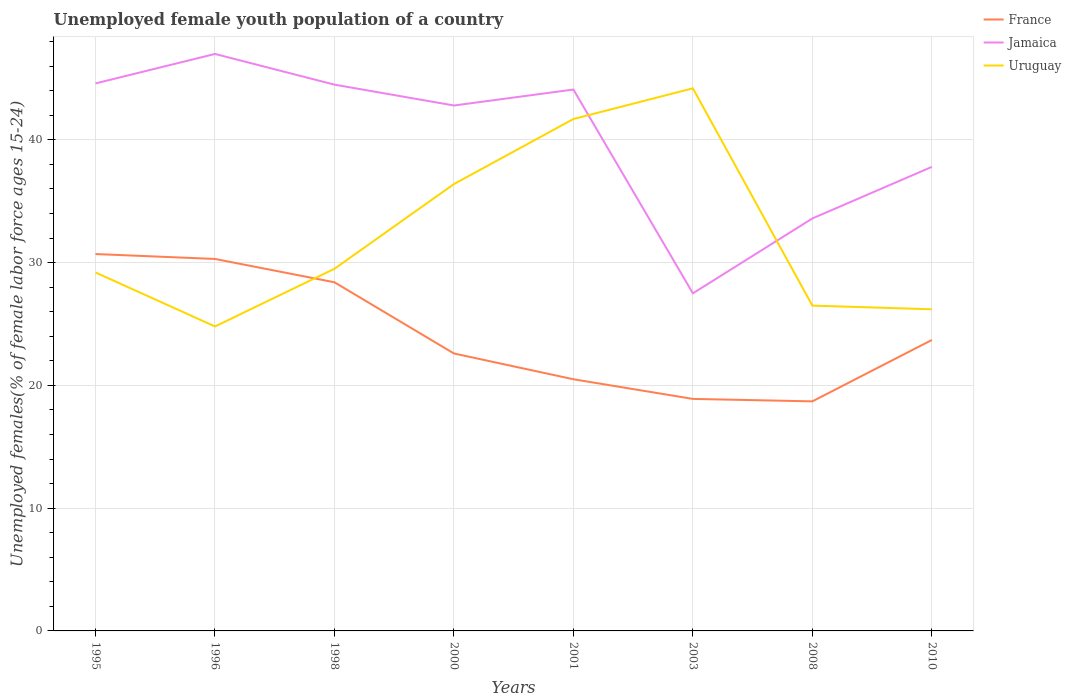Does the line corresponding to Jamaica intersect with the line corresponding to Uruguay?
Keep it short and to the point. Yes. What is the total percentage of unemployed female youth population in France in the graph?
Offer a very short reply. 6.6. What is the difference between the highest and the lowest percentage of unemployed female youth population in France?
Your answer should be compact. 3. How many years are there in the graph?
Your answer should be very brief. 8. What is the difference between two consecutive major ticks on the Y-axis?
Provide a short and direct response. 10. Are the values on the major ticks of Y-axis written in scientific E-notation?
Ensure brevity in your answer.  No. Does the graph contain any zero values?
Your answer should be compact. No. Does the graph contain grids?
Offer a very short reply. Yes. Where does the legend appear in the graph?
Your answer should be compact. Top right. What is the title of the graph?
Provide a succinct answer. Unemployed female youth population of a country. Does "Congo (Republic)" appear as one of the legend labels in the graph?
Keep it short and to the point. No. What is the label or title of the X-axis?
Provide a short and direct response. Years. What is the label or title of the Y-axis?
Ensure brevity in your answer.  Unemployed females(% of female labor force ages 15-24). What is the Unemployed females(% of female labor force ages 15-24) of France in 1995?
Provide a short and direct response. 30.7. What is the Unemployed females(% of female labor force ages 15-24) in Jamaica in 1995?
Ensure brevity in your answer.  44.6. What is the Unemployed females(% of female labor force ages 15-24) in Uruguay in 1995?
Offer a terse response. 29.2. What is the Unemployed females(% of female labor force ages 15-24) in France in 1996?
Your response must be concise. 30.3. What is the Unemployed females(% of female labor force ages 15-24) of Uruguay in 1996?
Your response must be concise. 24.8. What is the Unemployed females(% of female labor force ages 15-24) in France in 1998?
Provide a succinct answer. 28.4. What is the Unemployed females(% of female labor force ages 15-24) of Jamaica in 1998?
Provide a succinct answer. 44.5. What is the Unemployed females(% of female labor force ages 15-24) of Uruguay in 1998?
Offer a terse response. 29.5. What is the Unemployed females(% of female labor force ages 15-24) in France in 2000?
Make the answer very short. 22.6. What is the Unemployed females(% of female labor force ages 15-24) of Jamaica in 2000?
Give a very brief answer. 42.8. What is the Unemployed females(% of female labor force ages 15-24) in Uruguay in 2000?
Your response must be concise. 36.4. What is the Unemployed females(% of female labor force ages 15-24) of Jamaica in 2001?
Provide a short and direct response. 44.1. What is the Unemployed females(% of female labor force ages 15-24) of Uruguay in 2001?
Provide a short and direct response. 41.7. What is the Unemployed females(% of female labor force ages 15-24) of France in 2003?
Your answer should be compact. 18.9. What is the Unemployed females(% of female labor force ages 15-24) of Jamaica in 2003?
Provide a short and direct response. 27.5. What is the Unemployed females(% of female labor force ages 15-24) in Uruguay in 2003?
Ensure brevity in your answer.  44.2. What is the Unemployed females(% of female labor force ages 15-24) in France in 2008?
Offer a very short reply. 18.7. What is the Unemployed females(% of female labor force ages 15-24) of Jamaica in 2008?
Make the answer very short. 33.6. What is the Unemployed females(% of female labor force ages 15-24) in Uruguay in 2008?
Ensure brevity in your answer.  26.5. What is the Unemployed females(% of female labor force ages 15-24) of France in 2010?
Offer a terse response. 23.7. What is the Unemployed females(% of female labor force ages 15-24) of Jamaica in 2010?
Keep it short and to the point. 37.8. What is the Unemployed females(% of female labor force ages 15-24) in Uruguay in 2010?
Offer a terse response. 26.2. Across all years, what is the maximum Unemployed females(% of female labor force ages 15-24) in France?
Ensure brevity in your answer.  30.7. Across all years, what is the maximum Unemployed females(% of female labor force ages 15-24) in Uruguay?
Make the answer very short. 44.2. Across all years, what is the minimum Unemployed females(% of female labor force ages 15-24) in France?
Keep it short and to the point. 18.7. Across all years, what is the minimum Unemployed females(% of female labor force ages 15-24) in Uruguay?
Your answer should be very brief. 24.8. What is the total Unemployed females(% of female labor force ages 15-24) in France in the graph?
Provide a short and direct response. 193.8. What is the total Unemployed females(% of female labor force ages 15-24) of Jamaica in the graph?
Offer a very short reply. 321.9. What is the total Unemployed females(% of female labor force ages 15-24) in Uruguay in the graph?
Your response must be concise. 258.5. What is the difference between the Unemployed females(% of female labor force ages 15-24) in France in 1995 and that in 1996?
Give a very brief answer. 0.4. What is the difference between the Unemployed females(% of female labor force ages 15-24) in Uruguay in 1995 and that in 1996?
Offer a very short reply. 4.4. What is the difference between the Unemployed females(% of female labor force ages 15-24) of France in 1995 and that in 1998?
Provide a short and direct response. 2.3. What is the difference between the Unemployed females(% of female labor force ages 15-24) in Jamaica in 1995 and that in 1998?
Offer a very short reply. 0.1. What is the difference between the Unemployed females(% of female labor force ages 15-24) in France in 1995 and that in 2000?
Ensure brevity in your answer.  8.1. What is the difference between the Unemployed females(% of female labor force ages 15-24) in France in 1995 and that in 2008?
Provide a succinct answer. 12. What is the difference between the Unemployed females(% of female labor force ages 15-24) of Uruguay in 1995 and that in 2010?
Provide a short and direct response. 3. What is the difference between the Unemployed females(% of female labor force ages 15-24) of France in 1996 and that in 1998?
Your answer should be compact. 1.9. What is the difference between the Unemployed females(% of female labor force ages 15-24) of Jamaica in 1996 and that in 1998?
Make the answer very short. 2.5. What is the difference between the Unemployed females(% of female labor force ages 15-24) in Uruguay in 1996 and that in 1998?
Provide a short and direct response. -4.7. What is the difference between the Unemployed females(% of female labor force ages 15-24) of France in 1996 and that in 2000?
Offer a very short reply. 7.7. What is the difference between the Unemployed females(% of female labor force ages 15-24) of Uruguay in 1996 and that in 2000?
Give a very brief answer. -11.6. What is the difference between the Unemployed females(% of female labor force ages 15-24) in Uruguay in 1996 and that in 2001?
Your answer should be very brief. -16.9. What is the difference between the Unemployed females(% of female labor force ages 15-24) in Jamaica in 1996 and that in 2003?
Keep it short and to the point. 19.5. What is the difference between the Unemployed females(% of female labor force ages 15-24) of Uruguay in 1996 and that in 2003?
Keep it short and to the point. -19.4. What is the difference between the Unemployed females(% of female labor force ages 15-24) of France in 1996 and that in 2008?
Offer a terse response. 11.6. What is the difference between the Unemployed females(% of female labor force ages 15-24) in Jamaica in 1996 and that in 2008?
Make the answer very short. 13.4. What is the difference between the Unemployed females(% of female labor force ages 15-24) of Uruguay in 1996 and that in 2008?
Provide a succinct answer. -1.7. What is the difference between the Unemployed females(% of female labor force ages 15-24) in France in 1996 and that in 2010?
Your answer should be very brief. 6.6. What is the difference between the Unemployed females(% of female labor force ages 15-24) of Uruguay in 1996 and that in 2010?
Provide a succinct answer. -1.4. What is the difference between the Unemployed females(% of female labor force ages 15-24) in Uruguay in 1998 and that in 2000?
Make the answer very short. -6.9. What is the difference between the Unemployed females(% of female labor force ages 15-24) of Jamaica in 1998 and that in 2001?
Your answer should be very brief. 0.4. What is the difference between the Unemployed females(% of female labor force ages 15-24) of France in 1998 and that in 2003?
Keep it short and to the point. 9.5. What is the difference between the Unemployed females(% of female labor force ages 15-24) in Jamaica in 1998 and that in 2003?
Offer a very short reply. 17. What is the difference between the Unemployed females(% of female labor force ages 15-24) of Uruguay in 1998 and that in 2003?
Make the answer very short. -14.7. What is the difference between the Unemployed females(% of female labor force ages 15-24) in France in 1998 and that in 2010?
Ensure brevity in your answer.  4.7. What is the difference between the Unemployed females(% of female labor force ages 15-24) of Jamaica in 1998 and that in 2010?
Provide a succinct answer. 6.7. What is the difference between the Unemployed females(% of female labor force ages 15-24) in France in 2000 and that in 2003?
Make the answer very short. 3.7. What is the difference between the Unemployed females(% of female labor force ages 15-24) of Uruguay in 2000 and that in 2003?
Provide a short and direct response. -7.8. What is the difference between the Unemployed females(% of female labor force ages 15-24) in France in 2000 and that in 2008?
Ensure brevity in your answer.  3.9. What is the difference between the Unemployed females(% of female labor force ages 15-24) in Jamaica in 2000 and that in 2010?
Your response must be concise. 5. What is the difference between the Unemployed females(% of female labor force ages 15-24) of Uruguay in 2000 and that in 2010?
Ensure brevity in your answer.  10.2. What is the difference between the Unemployed females(% of female labor force ages 15-24) in Jamaica in 2001 and that in 2003?
Keep it short and to the point. 16.6. What is the difference between the Unemployed females(% of female labor force ages 15-24) of France in 2001 and that in 2008?
Your answer should be very brief. 1.8. What is the difference between the Unemployed females(% of female labor force ages 15-24) in Jamaica in 2001 and that in 2008?
Your response must be concise. 10.5. What is the difference between the Unemployed females(% of female labor force ages 15-24) of France in 2003 and that in 2008?
Your answer should be compact. 0.2. What is the difference between the Unemployed females(% of female labor force ages 15-24) of Uruguay in 2003 and that in 2008?
Provide a succinct answer. 17.7. What is the difference between the Unemployed females(% of female labor force ages 15-24) of France in 2003 and that in 2010?
Make the answer very short. -4.8. What is the difference between the Unemployed females(% of female labor force ages 15-24) in France in 2008 and that in 2010?
Keep it short and to the point. -5. What is the difference between the Unemployed females(% of female labor force ages 15-24) of Uruguay in 2008 and that in 2010?
Make the answer very short. 0.3. What is the difference between the Unemployed females(% of female labor force ages 15-24) of France in 1995 and the Unemployed females(% of female labor force ages 15-24) of Jamaica in 1996?
Offer a terse response. -16.3. What is the difference between the Unemployed females(% of female labor force ages 15-24) in Jamaica in 1995 and the Unemployed females(% of female labor force ages 15-24) in Uruguay in 1996?
Your answer should be very brief. 19.8. What is the difference between the Unemployed females(% of female labor force ages 15-24) of Jamaica in 1995 and the Unemployed females(% of female labor force ages 15-24) of Uruguay in 1998?
Make the answer very short. 15.1. What is the difference between the Unemployed females(% of female labor force ages 15-24) of France in 1995 and the Unemployed females(% of female labor force ages 15-24) of Uruguay in 2000?
Your answer should be very brief. -5.7. What is the difference between the Unemployed females(% of female labor force ages 15-24) of Jamaica in 1995 and the Unemployed females(% of female labor force ages 15-24) of Uruguay in 2000?
Offer a very short reply. 8.2. What is the difference between the Unemployed females(% of female labor force ages 15-24) of France in 1995 and the Unemployed females(% of female labor force ages 15-24) of Jamaica in 2001?
Your response must be concise. -13.4. What is the difference between the Unemployed females(% of female labor force ages 15-24) in Jamaica in 1995 and the Unemployed females(% of female labor force ages 15-24) in Uruguay in 2001?
Ensure brevity in your answer.  2.9. What is the difference between the Unemployed females(% of female labor force ages 15-24) in Jamaica in 1995 and the Unemployed females(% of female labor force ages 15-24) in Uruguay in 2003?
Provide a short and direct response. 0.4. What is the difference between the Unemployed females(% of female labor force ages 15-24) in France in 1995 and the Unemployed females(% of female labor force ages 15-24) in Jamaica in 2008?
Provide a short and direct response. -2.9. What is the difference between the Unemployed females(% of female labor force ages 15-24) of France in 1995 and the Unemployed females(% of female labor force ages 15-24) of Uruguay in 2008?
Your answer should be very brief. 4.2. What is the difference between the Unemployed females(% of female labor force ages 15-24) of Jamaica in 1996 and the Unemployed females(% of female labor force ages 15-24) of Uruguay in 1998?
Offer a very short reply. 17.5. What is the difference between the Unemployed females(% of female labor force ages 15-24) in France in 1996 and the Unemployed females(% of female labor force ages 15-24) in Uruguay in 2000?
Make the answer very short. -6.1. What is the difference between the Unemployed females(% of female labor force ages 15-24) in Jamaica in 1996 and the Unemployed females(% of female labor force ages 15-24) in Uruguay in 2000?
Keep it short and to the point. 10.6. What is the difference between the Unemployed females(% of female labor force ages 15-24) in France in 1996 and the Unemployed females(% of female labor force ages 15-24) in Jamaica in 2001?
Provide a succinct answer. -13.8. What is the difference between the Unemployed females(% of female labor force ages 15-24) in France in 1996 and the Unemployed females(% of female labor force ages 15-24) in Uruguay in 2001?
Give a very brief answer. -11.4. What is the difference between the Unemployed females(% of female labor force ages 15-24) in Jamaica in 1996 and the Unemployed females(% of female labor force ages 15-24) in Uruguay in 2001?
Keep it short and to the point. 5.3. What is the difference between the Unemployed females(% of female labor force ages 15-24) in France in 1996 and the Unemployed females(% of female labor force ages 15-24) in Jamaica in 2003?
Offer a terse response. 2.8. What is the difference between the Unemployed females(% of female labor force ages 15-24) of France in 1996 and the Unemployed females(% of female labor force ages 15-24) of Uruguay in 2008?
Provide a succinct answer. 3.8. What is the difference between the Unemployed females(% of female labor force ages 15-24) in Jamaica in 1996 and the Unemployed females(% of female labor force ages 15-24) in Uruguay in 2010?
Provide a succinct answer. 20.8. What is the difference between the Unemployed females(% of female labor force ages 15-24) in France in 1998 and the Unemployed females(% of female labor force ages 15-24) in Jamaica in 2000?
Your answer should be very brief. -14.4. What is the difference between the Unemployed females(% of female labor force ages 15-24) of Jamaica in 1998 and the Unemployed females(% of female labor force ages 15-24) of Uruguay in 2000?
Give a very brief answer. 8.1. What is the difference between the Unemployed females(% of female labor force ages 15-24) of France in 1998 and the Unemployed females(% of female labor force ages 15-24) of Jamaica in 2001?
Ensure brevity in your answer.  -15.7. What is the difference between the Unemployed females(% of female labor force ages 15-24) in Jamaica in 1998 and the Unemployed females(% of female labor force ages 15-24) in Uruguay in 2001?
Keep it short and to the point. 2.8. What is the difference between the Unemployed females(% of female labor force ages 15-24) in France in 1998 and the Unemployed females(% of female labor force ages 15-24) in Uruguay in 2003?
Make the answer very short. -15.8. What is the difference between the Unemployed females(% of female labor force ages 15-24) in Jamaica in 1998 and the Unemployed females(% of female labor force ages 15-24) in Uruguay in 2003?
Provide a succinct answer. 0.3. What is the difference between the Unemployed females(% of female labor force ages 15-24) in France in 1998 and the Unemployed females(% of female labor force ages 15-24) in Jamaica in 2008?
Offer a very short reply. -5.2. What is the difference between the Unemployed females(% of female labor force ages 15-24) of Jamaica in 1998 and the Unemployed females(% of female labor force ages 15-24) of Uruguay in 2008?
Ensure brevity in your answer.  18. What is the difference between the Unemployed females(% of female labor force ages 15-24) of France in 1998 and the Unemployed females(% of female labor force ages 15-24) of Uruguay in 2010?
Provide a succinct answer. 2.2. What is the difference between the Unemployed females(% of female labor force ages 15-24) of France in 2000 and the Unemployed females(% of female labor force ages 15-24) of Jamaica in 2001?
Make the answer very short. -21.5. What is the difference between the Unemployed females(% of female labor force ages 15-24) of France in 2000 and the Unemployed females(% of female labor force ages 15-24) of Uruguay in 2001?
Your answer should be compact. -19.1. What is the difference between the Unemployed females(% of female labor force ages 15-24) in France in 2000 and the Unemployed females(% of female labor force ages 15-24) in Uruguay in 2003?
Your response must be concise. -21.6. What is the difference between the Unemployed females(% of female labor force ages 15-24) in France in 2000 and the Unemployed females(% of female labor force ages 15-24) in Jamaica in 2008?
Keep it short and to the point. -11. What is the difference between the Unemployed females(% of female labor force ages 15-24) of France in 2000 and the Unemployed females(% of female labor force ages 15-24) of Jamaica in 2010?
Keep it short and to the point. -15.2. What is the difference between the Unemployed females(% of female labor force ages 15-24) of France in 2001 and the Unemployed females(% of female labor force ages 15-24) of Uruguay in 2003?
Keep it short and to the point. -23.7. What is the difference between the Unemployed females(% of female labor force ages 15-24) of Jamaica in 2001 and the Unemployed females(% of female labor force ages 15-24) of Uruguay in 2003?
Make the answer very short. -0.1. What is the difference between the Unemployed females(% of female labor force ages 15-24) of France in 2001 and the Unemployed females(% of female labor force ages 15-24) of Jamaica in 2008?
Your response must be concise. -13.1. What is the difference between the Unemployed females(% of female labor force ages 15-24) in Jamaica in 2001 and the Unemployed females(% of female labor force ages 15-24) in Uruguay in 2008?
Ensure brevity in your answer.  17.6. What is the difference between the Unemployed females(% of female labor force ages 15-24) in France in 2001 and the Unemployed females(% of female labor force ages 15-24) in Jamaica in 2010?
Provide a succinct answer. -17.3. What is the difference between the Unemployed females(% of female labor force ages 15-24) in France in 2001 and the Unemployed females(% of female labor force ages 15-24) in Uruguay in 2010?
Offer a very short reply. -5.7. What is the difference between the Unemployed females(% of female labor force ages 15-24) of Jamaica in 2001 and the Unemployed females(% of female labor force ages 15-24) of Uruguay in 2010?
Your answer should be compact. 17.9. What is the difference between the Unemployed females(% of female labor force ages 15-24) of France in 2003 and the Unemployed females(% of female labor force ages 15-24) of Jamaica in 2008?
Provide a succinct answer. -14.7. What is the difference between the Unemployed females(% of female labor force ages 15-24) of France in 2003 and the Unemployed females(% of female labor force ages 15-24) of Jamaica in 2010?
Your answer should be very brief. -18.9. What is the difference between the Unemployed females(% of female labor force ages 15-24) in France in 2003 and the Unemployed females(% of female labor force ages 15-24) in Uruguay in 2010?
Your answer should be very brief. -7.3. What is the difference between the Unemployed females(% of female labor force ages 15-24) in France in 2008 and the Unemployed females(% of female labor force ages 15-24) in Jamaica in 2010?
Offer a very short reply. -19.1. What is the difference between the Unemployed females(% of female labor force ages 15-24) in France in 2008 and the Unemployed females(% of female labor force ages 15-24) in Uruguay in 2010?
Provide a succinct answer. -7.5. What is the difference between the Unemployed females(% of female labor force ages 15-24) of Jamaica in 2008 and the Unemployed females(% of female labor force ages 15-24) of Uruguay in 2010?
Provide a short and direct response. 7.4. What is the average Unemployed females(% of female labor force ages 15-24) of France per year?
Your answer should be compact. 24.23. What is the average Unemployed females(% of female labor force ages 15-24) of Jamaica per year?
Offer a terse response. 40.24. What is the average Unemployed females(% of female labor force ages 15-24) of Uruguay per year?
Your response must be concise. 32.31. In the year 1995, what is the difference between the Unemployed females(% of female labor force ages 15-24) in France and Unemployed females(% of female labor force ages 15-24) in Jamaica?
Make the answer very short. -13.9. In the year 1996, what is the difference between the Unemployed females(% of female labor force ages 15-24) of France and Unemployed females(% of female labor force ages 15-24) of Jamaica?
Keep it short and to the point. -16.7. In the year 1996, what is the difference between the Unemployed females(% of female labor force ages 15-24) in France and Unemployed females(% of female labor force ages 15-24) in Uruguay?
Offer a terse response. 5.5. In the year 1998, what is the difference between the Unemployed females(% of female labor force ages 15-24) of France and Unemployed females(% of female labor force ages 15-24) of Jamaica?
Provide a short and direct response. -16.1. In the year 1998, what is the difference between the Unemployed females(% of female labor force ages 15-24) of Jamaica and Unemployed females(% of female labor force ages 15-24) of Uruguay?
Give a very brief answer. 15. In the year 2000, what is the difference between the Unemployed females(% of female labor force ages 15-24) in France and Unemployed females(% of female labor force ages 15-24) in Jamaica?
Keep it short and to the point. -20.2. In the year 2000, what is the difference between the Unemployed females(% of female labor force ages 15-24) in Jamaica and Unemployed females(% of female labor force ages 15-24) in Uruguay?
Your answer should be very brief. 6.4. In the year 2001, what is the difference between the Unemployed females(% of female labor force ages 15-24) in France and Unemployed females(% of female labor force ages 15-24) in Jamaica?
Give a very brief answer. -23.6. In the year 2001, what is the difference between the Unemployed females(% of female labor force ages 15-24) in France and Unemployed females(% of female labor force ages 15-24) in Uruguay?
Keep it short and to the point. -21.2. In the year 2001, what is the difference between the Unemployed females(% of female labor force ages 15-24) of Jamaica and Unemployed females(% of female labor force ages 15-24) of Uruguay?
Your answer should be compact. 2.4. In the year 2003, what is the difference between the Unemployed females(% of female labor force ages 15-24) of France and Unemployed females(% of female labor force ages 15-24) of Uruguay?
Provide a succinct answer. -25.3. In the year 2003, what is the difference between the Unemployed females(% of female labor force ages 15-24) in Jamaica and Unemployed females(% of female labor force ages 15-24) in Uruguay?
Give a very brief answer. -16.7. In the year 2008, what is the difference between the Unemployed females(% of female labor force ages 15-24) in France and Unemployed females(% of female labor force ages 15-24) in Jamaica?
Keep it short and to the point. -14.9. In the year 2008, what is the difference between the Unemployed females(% of female labor force ages 15-24) of Jamaica and Unemployed females(% of female labor force ages 15-24) of Uruguay?
Offer a terse response. 7.1. In the year 2010, what is the difference between the Unemployed females(% of female labor force ages 15-24) of France and Unemployed females(% of female labor force ages 15-24) of Jamaica?
Provide a short and direct response. -14.1. What is the ratio of the Unemployed females(% of female labor force ages 15-24) of France in 1995 to that in 1996?
Keep it short and to the point. 1.01. What is the ratio of the Unemployed females(% of female labor force ages 15-24) in Jamaica in 1995 to that in 1996?
Offer a terse response. 0.95. What is the ratio of the Unemployed females(% of female labor force ages 15-24) in Uruguay in 1995 to that in 1996?
Give a very brief answer. 1.18. What is the ratio of the Unemployed females(% of female labor force ages 15-24) in France in 1995 to that in 1998?
Give a very brief answer. 1.08. What is the ratio of the Unemployed females(% of female labor force ages 15-24) of France in 1995 to that in 2000?
Make the answer very short. 1.36. What is the ratio of the Unemployed females(% of female labor force ages 15-24) of Jamaica in 1995 to that in 2000?
Keep it short and to the point. 1.04. What is the ratio of the Unemployed females(% of female labor force ages 15-24) in Uruguay in 1995 to that in 2000?
Offer a terse response. 0.8. What is the ratio of the Unemployed females(% of female labor force ages 15-24) of France in 1995 to that in 2001?
Your response must be concise. 1.5. What is the ratio of the Unemployed females(% of female labor force ages 15-24) of Jamaica in 1995 to that in 2001?
Your answer should be compact. 1.01. What is the ratio of the Unemployed females(% of female labor force ages 15-24) of Uruguay in 1995 to that in 2001?
Provide a succinct answer. 0.7. What is the ratio of the Unemployed females(% of female labor force ages 15-24) of France in 1995 to that in 2003?
Your answer should be compact. 1.62. What is the ratio of the Unemployed females(% of female labor force ages 15-24) of Jamaica in 1995 to that in 2003?
Your response must be concise. 1.62. What is the ratio of the Unemployed females(% of female labor force ages 15-24) of Uruguay in 1995 to that in 2003?
Offer a very short reply. 0.66. What is the ratio of the Unemployed females(% of female labor force ages 15-24) of France in 1995 to that in 2008?
Provide a succinct answer. 1.64. What is the ratio of the Unemployed females(% of female labor force ages 15-24) of Jamaica in 1995 to that in 2008?
Offer a terse response. 1.33. What is the ratio of the Unemployed females(% of female labor force ages 15-24) in Uruguay in 1995 to that in 2008?
Provide a succinct answer. 1.1. What is the ratio of the Unemployed females(% of female labor force ages 15-24) of France in 1995 to that in 2010?
Offer a very short reply. 1.3. What is the ratio of the Unemployed females(% of female labor force ages 15-24) of Jamaica in 1995 to that in 2010?
Keep it short and to the point. 1.18. What is the ratio of the Unemployed females(% of female labor force ages 15-24) in Uruguay in 1995 to that in 2010?
Give a very brief answer. 1.11. What is the ratio of the Unemployed females(% of female labor force ages 15-24) in France in 1996 to that in 1998?
Offer a very short reply. 1.07. What is the ratio of the Unemployed females(% of female labor force ages 15-24) of Jamaica in 1996 to that in 1998?
Provide a succinct answer. 1.06. What is the ratio of the Unemployed females(% of female labor force ages 15-24) in Uruguay in 1996 to that in 1998?
Ensure brevity in your answer.  0.84. What is the ratio of the Unemployed females(% of female labor force ages 15-24) in France in 1996 to that in 2000?
Provide a succinct answer. 1.34. What is the ratio of the Unemployed females(% of female labor force ages 15-24) in Jamaica in 1996 to that in 2000?
Your answer should be compact. 1.1. What is the ratio of the Unemployed females(% of female labor force ages 15-24) of Uruguay in 1996 to that in 2000?
Offer a terse response. 0.68. What is the ratio of the Unemployed females(% of female labor force ages 15-24) in France in 1996 to that in 2001?
Your answer should be compact. 1.48. What is the ratio of the Unemployed females(% of female labor force ages 15-24) of Jamaica in 1996 to that in 2001?
Give a very brief answer. 1.07. What is the ratio of the Unemployed females(% of female labor force ages 15-24) of Uruguay in 1996 to that in 2001?
Make the answer very short. 0.59. What is the ratio of the Unemployed females(% of female labor force ages 15-24) of France in 1996 to that in 2003?
Your answer should be very brief. 1.6. What is the ratio of the Unemployed females(% of female labor force ages 15-24) of Jamaica in 1996 to that in 2003?
Provide a succinct answer. 1.71. What is the ratio of the Unemployed females(% of female labor force ages 15-24) of Uruguay in 1996 to that in 2003?
Your answer should be compact. 0.56. What is the ratio of the Unemployed females(% of female labor force ages 15-24) in France in 1996 to that in 2008?
Ensure brevity in your answer.  1.62. What is the ratio of the Unemployed females(% of female labor force ages 15-24) in Jamaica in 1996 to that in 2008?
Keep it short and to the point. 1.4. What is the ratio of the Unemployed females(% of female labor force ages 15-24) in Uruguay in 1996 to that in 2008?
Offer a very short reply. 0.94. What is the ratio of the Unemployed females(% of female labor force ages 15-24) of France in 1996 to that in 2010?
Offer a terse response. 1.28. What is the ratio of the Unemployed females(% of female labor force ages 15-24) in Jamaica in 1996 to that in 2010?
Provide a short and direct response. 1.24. What is the ratio of the Unemployed females(% of female labor force ages 15-24) in Uruguay in 1996 to that in 2010?
Provide a succinct answer. 0.95. What is the ratio of the Unemployed females(% of female labor force ages 15-24) of France in 1998 to that in 2000?
Make the answer very short. 1.26. What is the ratio of the Unemployed females(% of female labor force ages 15-24) of Jamaica in 1998 to that in 2000?
Make the answer very short. 1.04. What is the ratio of the Unemployed females(% of female labor force ages 15-24) of Uruguay in 1998 to that in 2000?
Ensure brevity in your answer.  0.81. What is the ratio of the Unemployed females(% of female labor force ages 15-24) of France in 1998 to that in 2001?
Offer a very short reply. 1.39. What is the ratio of the Unemployed females(% of female labor force ages 15-24) of Jamaica in 1998 to that in 2001?
Your answer should be compact. 1.01. What is the ratio of the Unemployed females(% of female labor force ages 15-24) of Uruguay in 1998 to that in 2001?
Your answer should be very brief. 0.71. What is the ratio of the Unemployed females(% of female labor force ages 15-24) in France in 1998 to that in 2003?
Offer a terse response. 1.5. What is the ratio of the Unemployed females(% of female labor force ages 15-24) of Jamaica in 1998 to that in 2003?
Give a very brief answer. 1.62. What is the ratio of the Unemployed females(% of female labor force ages 15-24) of Uruguay in 1998 to that in 2003?
Provide a short and direct response. 0.67. What is the ratio of the Unemployed females(% of female labor force ages 15-24) in France in 1998 to that in 2008?
Provide a succinct answer. 1.52. What is the ratio of the Unemployed females(% of female labor force ages 15-24) of Jamaica in 1998 to that in 2008?
Your answer should be compact. 1.32. What is the ratio of the Unemployed females(% of female labor force ages 15-24) in Uruguay in 1998 to that in 2008?
Your answer should be very brief. 1.11. What is the ratio of the Unemployed females(% of female labor force ages 15-24) in France in 1998 to that in 2010?
Provide a short and direct response. 1.2. What is the ratio of the Unemployed females(% of female labor force ages 15-24) of Jamaica in 1998 to that in 2010?
Provide a succinct answer. 1.18. What is the ratio of the Unemployed females(% of female labor force ages 15-24) of Uruguay in 1998 to that in 2010?
Give a very brief answer. 1.13. What is the ratio of the Unemployed females(% of female labor force ages 15-24) of France in 2000 to that in 2001?
Keep it short and to the point. 1.1. What is the ratio of the Unemployed females(% of female labor force ages 15-24) in Jamaica in 2000 to that in 2001?
Your answer should be very brief. 0.97. What is the ratio of the Unemployed females(% of female labor force ages 15-24) of Uruguay in 2000 to that in 2001?
Provide a short and direct response. 0.87. What is the ratio of the Unemployed females(% of female labor force ages 15-24) of France in 2000 to that in 2003?
Your answer should be compact. 1.2. What is the ratio of the Unemployed females(% of female labor force ages 15-24) in Jamaica in 2000 to that in 2003?
Offer a terse response. 1.56. What is the ratio of the Unemployed females(% of female labor force ages 15-24) in Uruguay in 2000 to that in 2003?
Make the answer very short. 0.82. What is the ratio of the Unemployed females(% of female labor force ages 15-24) in France in 2000 to that in 2008?
Give a very brief answer. 1.21. What is the ratio of the Unemployed females(% of female labor force ages 15-24) of Jamaica in 2000 to that in 2008?
Your response must be concise. 1.27. What is the ratio of the Unemployed females(% of female labor force ages 15-24) in Uruguay in 2000 to that in 2008?
Keep it short and to the point. 1.37. What is the ratio of the Unemployed females(% of female labor force ages 15-24) of France in 2000 to that in 2010?
Your answer should be compact. 0.95. What is the ratio of the Unemployed females(% of female labor force ages 15-24) of Jamaica in 2000 to that in 2010?
Ensure brevity in your answer.  1.13. What is the ratio of the Unemployed females(% of female labor force ages 15-24) of Uruguay in 2000 to that in 2010?
Provide a short and direct response. 1.39. What is the ratio of the Unemployed females(% of female labor force ages 15-24) of France in 2001 to that in 2003?
Provide a short and direct response. 1.08. What is the ratio of the Unemployed females(% of female labor force ages 15-24) in Jamaica in 2001 to that in 2003?
Provide a short and direct response. 1.6. What is the ratio of the Unemployed females(% of female labor force ages 15-24) in Uruguay in 2001 to that in 2003?
Keep it short and to the point. 0.94. What is the ratio of the Unemployed females(% of female labor force ages 15-24) in France in 2001 to that in 2008?
Give a very brief answer. 1.1. What is the ratio of the Unemployed females(% of female labor force ages 15-24) in Jamaica in 2001 to that in 2008?
Give a very brief answer. 1.31. What is the ratio of the Unemployed females(% of female labor force ages 15-24) of Uruguay in 2001 to that in 2008?
Ensure brevity in your answer.  1.57. What is the ratio of the Unemployed females(% of female labor force ages 15-24) of France in 2001 to that in 2010?
Ensure brevity in your answer.  0.86. What is the ratio of the Unemployed females(% of female labor force ages 15-24) of Uruguay in 2001 to that in 2010?
Keep it short and to the point. 1.59. What is the ratio of the Unemployed females(% of female labor force ages 15-24) in France in 2003 to that in 2008?
Offer a terse response. 1.01. What is the ratio of the Unemployed females(% of female labor force ages 15-24) in Jamaica in 2003 to that in 2008?
Offer a very short reply. 0.82. What is the ratio of the Unemployed females(% of female labor force ages 15-24) of Uruguay in 2003 to that in 2008?
Make the answer very short. 1.67. What is the ratio of the Unemployed females(% of female labor force ages 15-24) in France in 2003 to that in 2010?
Give a very brief answer. 0.8. What is the ratio of the Unemployed females(% of female labor force ages 15-24) in Jamaica in 2003 to that in 2010?
Give a very brief answer. 0.73. What is the ratio of the Unemployed females(% of female labor force ages 15-24) in Uruguay in 2003 to that in 2010?
Offer a terse response. 1.69. What is the ratio of the Unemployed females(% of female labor force ages 15-24) in France in 2008 to that in 2010?
Offer a terse response. 0.79. What is the ratio of the Unemployed females(% of female labor force ages 15-24) of Uruguay in 2008 to that in 2010?
Ensure brevity in your answer.  1.01. What is the difference between the highest and the second highest Unemployed females(% of female labor force ages 15-24) of France?
Offer a very short reply. 0.4. What is the difference between the highest and the second highest Unemployed females(% of female labor force ages 15-24) of Uruguay?
Offer a very short reply. 2.5. What is the difference between the highest and the lowest Unemployed females(% of female labor force ages 15-24) of France?
Offer a terse response. 12. What is the difference between the highest and the lowest Unemployed females(% of female labor force ages 15-24) of Jamaica?
Give a very brief answer. 19.5. What is the difference between the highest and the lowest Unemployed females(% of female labor force ages 15-24) of Uruguay?
Offer a terse response. 19.4. 